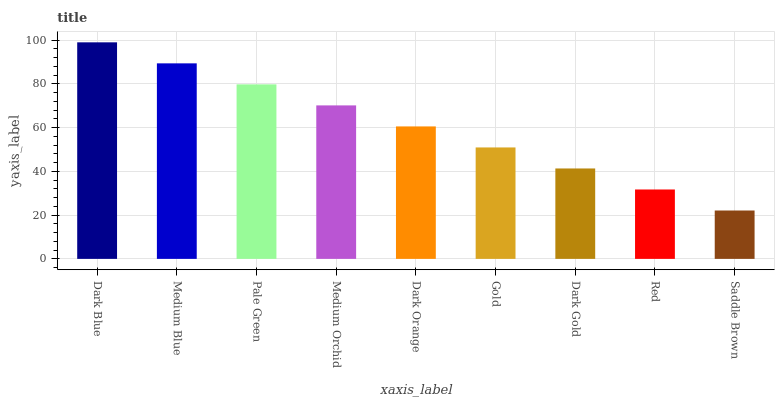Is Saddle Brown the minimum?
Answer yes or no. Yes. Is Dark Blue the maximum?
Answer yes or no. Yes. Is Medium Blue the minimum?
Answer yes or no. No. Is Medium Blue the maximum?
Answer yes or no. No. Is Dark Blue greater than Medium Blue?
Answer yes or no. Yes. Is Medium Blue less than Dark Blue?
Answer yes or no. Yes. Is Medium Blue greater than Dark Blue?
Answer yes or no. No. Is Dark Blue less than Medium Blue?
Answer yes or no. No. Is Dark Orange the high median?
Answer yes or no. Yes. Is Dark Orange the low median?
Answer yes or no. Yes. Is Medium Blue the high median?
Answer yes or no. No. Is Dark Blue the low median?
Answer yes or no. No. 